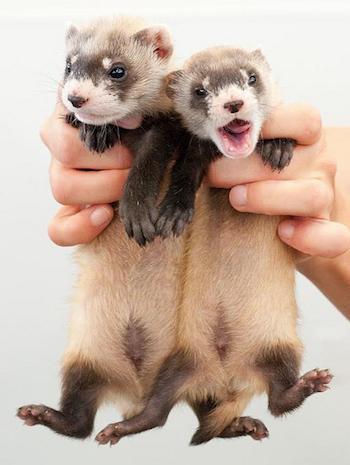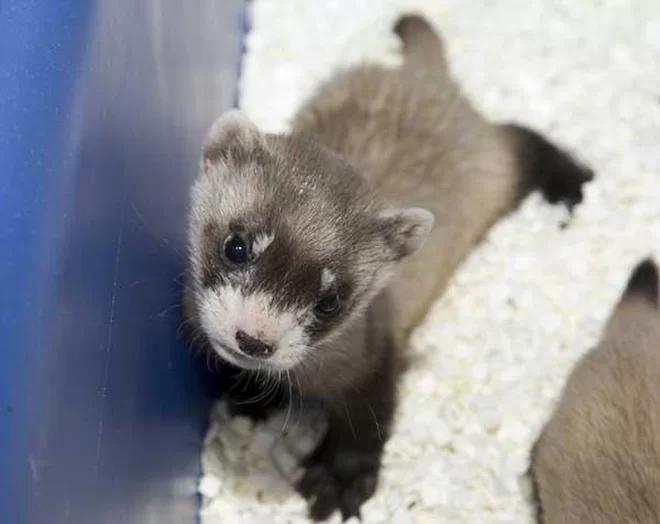The first image is the image on the left, the second image is the image on the right. Examine the images to the left and right. Is the description "At least one baby ferret is being held by a human hand." accurate? Answer yes or no. Yes. The first image is the image on the left, the second image is the image on the right. For the images shown, is this caption "At least four ferrets are in the same container in one image." true? Answer yes or no. No. 